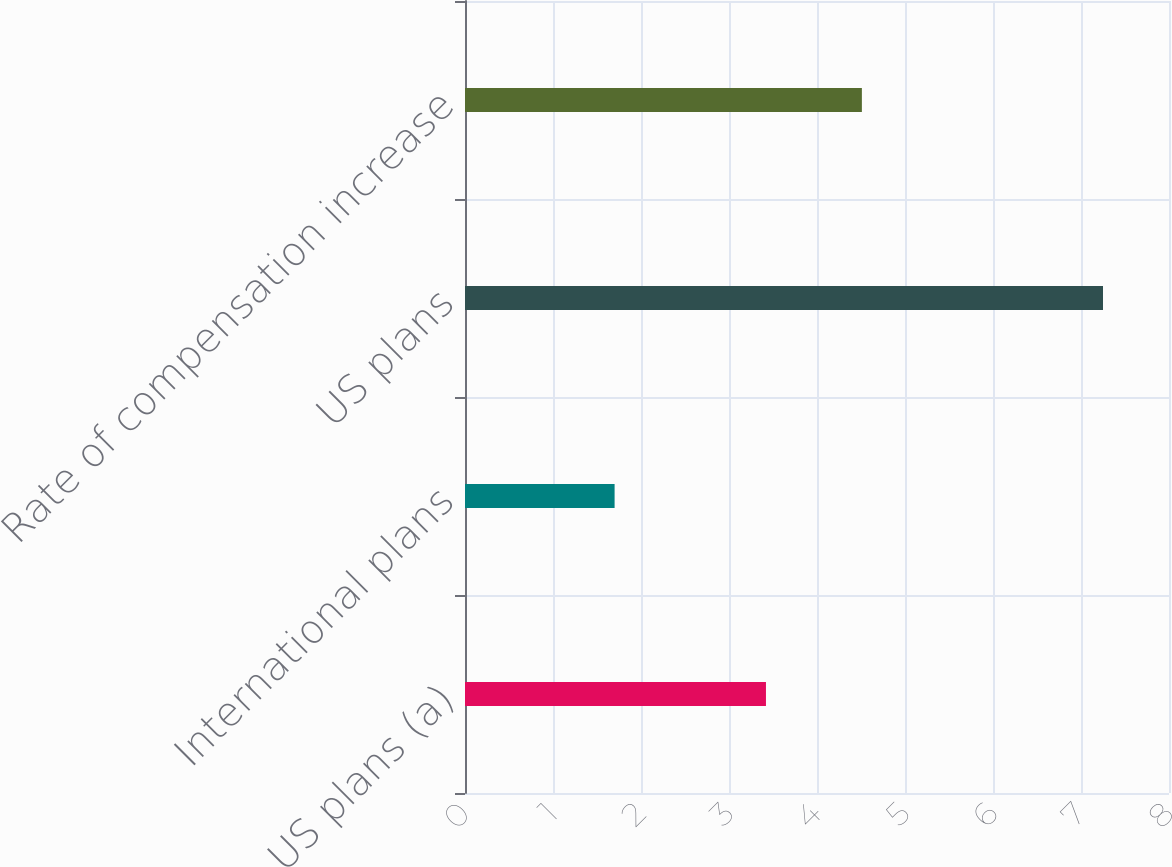<chart> <loc_0><loc_0><loc_500><loc_500><bar_chart><fcel>US plans (a)<fcel>International plans<fcel>US plans<fcel>Rate of compensation increase<nl><fcel>3.42<fcel>1.7<fcel>7.25<fcel>4.51<nl></chart> 